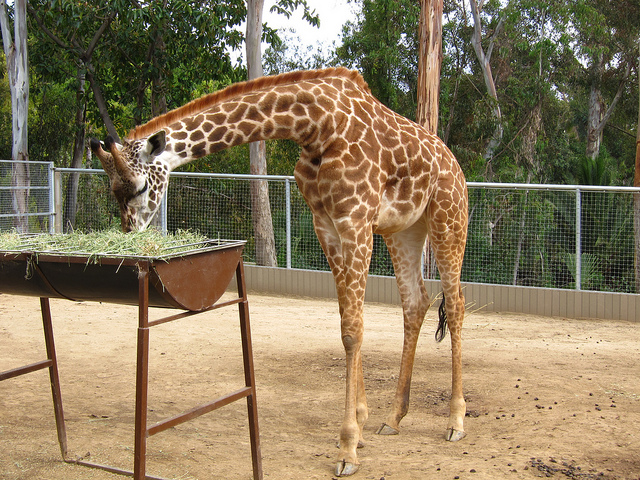What type of animal is this and what is it doing? This is a giraffe, identifiable by its long neck and spotted coat. It's eating hay, which is likely a part of its daily diet at the zoo. Can you tell me more about giraffe's diet? Certainly! Giraffes are herbivores, primarily feeding on leaves, fruits, and flowers, which they typically get from tall trees in the wild. In a zoo setting, they are often fed a variety of vegetation, including hay, to ensure they receive the necessary nutrients. 